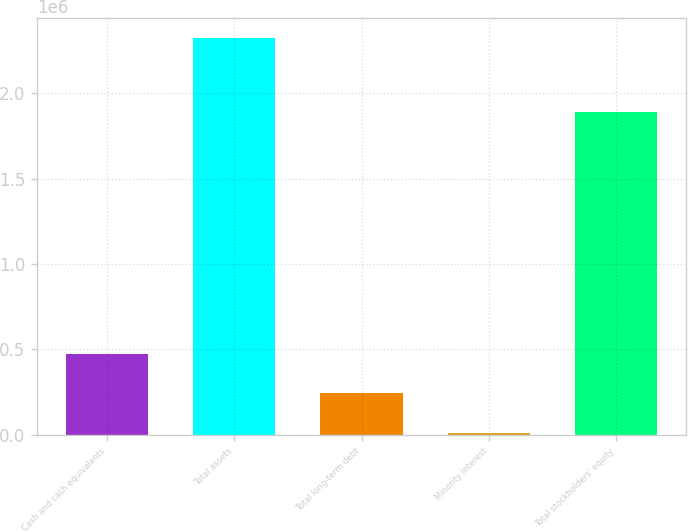<chart> <loc_0><loc_0><loc_500><loc_500><bar_chart><fcel>Cash and cash equivalents<fcel>Total assets<fcel>Total long-term debt<fcel>Minority interest<fcel>Total stockholders' equity<nl><fcel>475121<fcel>2.32708e+06<fcel>243626<fcel>12130<fcel>1.8908e+06<nl></chart> 